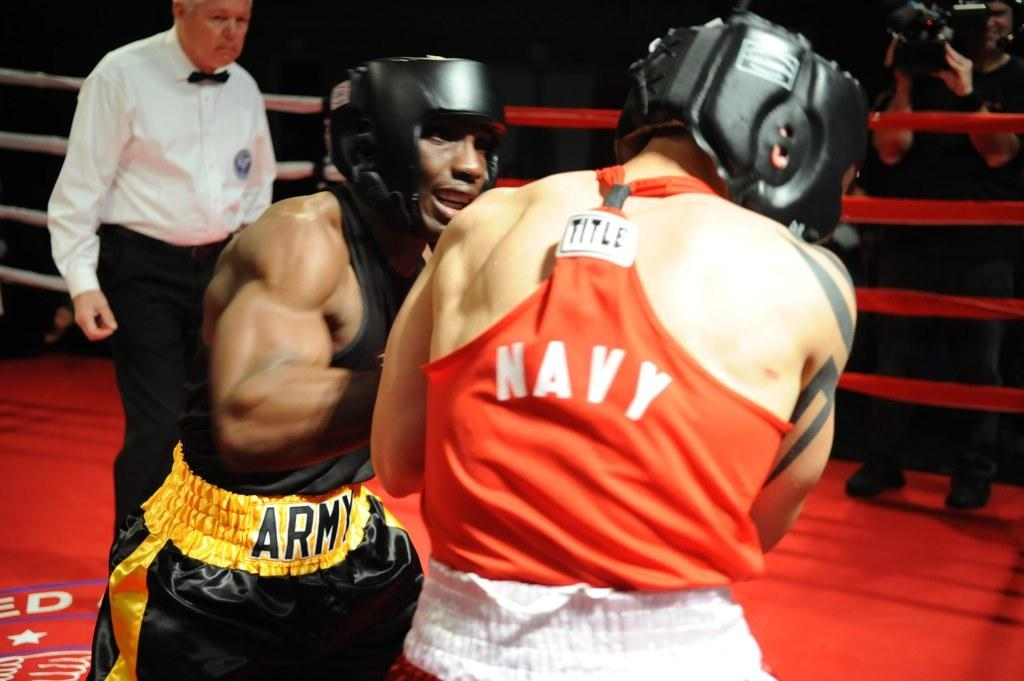<image>
Summarize the visual content of the image. Man wearing an orange top which says NAVY on it. 